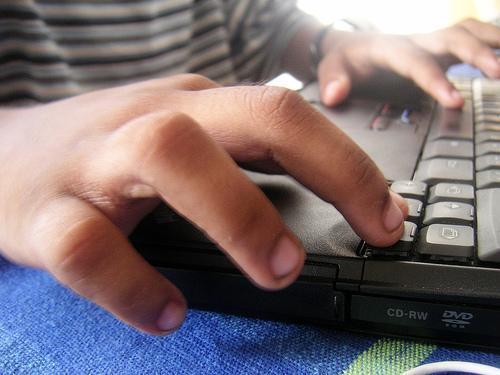How many people are pictured?
Give a very brief answer. 1. 